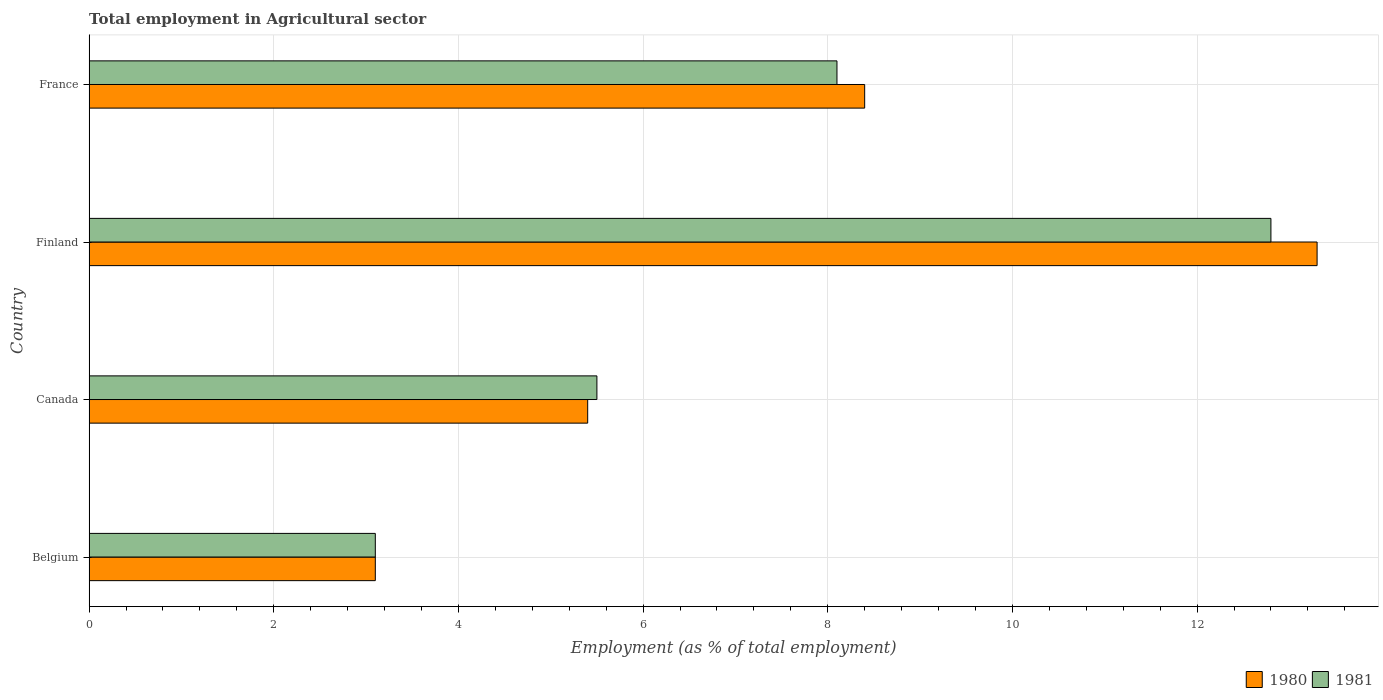How many groups of bars are there?
Provide a succinct answer. 4. Are the number of bars on each tick of the Y-axis equal?
Offer a very short reply. Yes. How many bars are there on the 4th tick from the top?
Your response must be concise. 2. What is the employment in agricultural sector in 1981 in Finland?
Provide a short and direct response. 12.8. Across all countries, what is the maximum employment in agricultural sector in 1980?
Ensure brevity in your answer.  13.3. Across all countries, what is the minimum employment in agricultural sector in 1980?
Keep it short and to the point. 3.1. In which country was the employment in agricultural sector in 1980 maximum?
Provide a succinct answer. Finland. In which country was the employment in agricultural sector in 1981 minimum?
Ensure brevity in your answer.  Belgium. What is the total employment in agricultural sector in 1980 in the graph?
Offer a terse response. 30.2. What is the difference between the employment in agricultural sector in 1981 in Canada and that in France?
Provide a short and direct response. -2.6. What is the difference between the employment in agricultural sector in 1981 in Finland and the employment in agricultural sector in 1980 in Belgium?
Your response must be concise. 9.7. What is the average employment in agricultural sector in 1980 per country?
Ensure brevity in your answer.  7.55. What is the difference between the employment in agricultural sector in 1980 and employment in agricultural sector in 1981 in France?
Ensure brevity in your answer.  0.3. What is the ratio of the employment in agricultural sector in 1981 in Canada to that in Finland?
Provide a succinct answer. 0.43. What is the difference between the highest and the second highest employment in agricultural sector in 1980?
Provide a succinct answer. 4.9. What is the difference between the highest and the lowest employment in agricultural sector in 1980?
Provide a short and direct response. 10.2. Is the sum of the employment in agricultural sector in 1980 in Finland and France greater than the maximum employment in agricultural sector in 1981 across all countries?
Your response must be concise. Yes. How many bars are there?
Offer a very short reply. 8. How many countries are there in the graph?
Your response must be concise. 4. What is the difference between two consecutive major ticks on the X-axis?
Provide a short and direct response. 2. Does the graph contain any zero values?
Provide a short and direct response. No. Where does the legend appear in the graph?
Make the answer very short. Bottom right. How many legend labels are there?
Your answer should be very brief. 2. How are the legend labels stacked?
Keep it short and to the point. Horizontal. What is the title of the graph?
Provide a short and direct response. Total employment in Agricultural sector. What is the label or title of the X-axis?
Give a very brief answer. Employment (as % of total employment). What is the label or title of the Y-axis?
Give a very brief answer. Country. What is the Employment (as % of total employment) of 1980 in Belgium?
Provide a succinct answer. 3.1. What is the Employment (as % of total employment) of 1981 in Belgium?
Provide a short and direct response. 3.1. What is the Employment (as % of total employment) in 1980 in Canada?
Your response must be concise. 5.4. What is the Employment (as % of total employment) of 1980 in Finland?
Give a very brief answer. 13.3. What is the Employment (as % of total employment) in 1981 in Finland?
Give a very brief answer. 12.8. What is the Employment (as % of total employment) in 1980 in France?
Ensure brevity in your answer.  8.4. What is the Employment (as % of total employment) of 1981 in France?
Give a very brief answer. 8.1. Across all countries, what is the maximum Employment (as % of total employment) of 1980?
Ensure brevity in your answer.  13.3. Across all countries, what is the maximum Employment (as % of total employment) in 1981?
Provide a succinct answer. 12.8. Across all countries, what is the minimum Employment (as % of total employment) of 1980?
Keep it short and to the point. 3.1. Across all countries, what is the minimum Employment (as % of total employment) in 1981?
Provide a succinct answer. 3.1. What is the total Employment (as % of total employment) in 1980 in the graph?
Ensure brevity in your answer.  30.2. What is the total Employment (as % of total employment) of 1981 in the graph?
Make the answer very short. 29.5. What is the difference between the Employment (as % of total employment) of 1980 in Belgium and that in Canada?
Provide a short and direct response. -2.3. What is the difference between the Employment (as % of total employment) in 1981 in Belgium and that in Canada?
Provide a short and direct response. -2.4. What is the difference between the Employment (as % of total employment) in 1981 in Belgium and that in Finland?
Give a very brief answer. -9.7. What is the difference between the Employment (as % of total employment) in 1980 in Belgium and that in France?
Your answer should be compact. -5.3. What is the difference between the Employment (as % of total employment) of 1981 in Belgium and that in France?
Offer a very short reply. -5. What is the difference between the Employment (as % of total employment) in 1980 in Canada and that in Finland?
Your answer should be compact. -7.9. What is the difference between the Employment (as % of total employment) of 1981 in Canada and that in Finland?
Offer a terse response. -7.3. What is the difference between the Employment (as % of total employment) in 1980 in Canada and that in France?
Provide a succinct answer. -3. What is the difference between the Employment (as % of total employment) of 1980 in Finland and that in France?
Ensure brevity in your answer.  4.9. What is the difference between the Employment (as % of total employment) of 1981 in Finland and that in France?
Your answer should be compact. 4.7. What is the difference between the Employment (as % of total employment) of 1980 in Belgium and the Employment (as % of total employment) of 1981 in France?
Make the answer very short. -5. What is the average Employment (as % of total employment) in 1980 per country?
Provide a short and direct response. 7.55. What is the average Employment (as % of total employment) in 1981 per country?
Give a very brief answer. 7.38. What is the difference between the Employment (as % of total employment) in 1980 and Employment (as % of total employment) in 1981 in Belgium?
Provide a short and direct response. 0. What is the difference between the Employment (as % of total employment) in 1980 and Employment (as % of total employment) in 1981 in Canada?
Give a very brief answer. -0.1. What is the difference between the Employment (as % of total employment) in 1980 and Employment (as % of total employment) in 1981 in Finland?
Your answer should be very brief. 0.5. What is the difference between the Employment (as % of total employment) in 1980 and Employment (as % of total employment) in 1981 in France?
Give a very brief answer. 0.3. What is the ratio of the Employment (as % of total employment) of 1980 in Belgium to that in Canada?
Your answer should be compact. 0.57. What is the ratio of the Employment (as % of total employment) of 1981 in Belgium to that in Canada?
Offer a very short reply. 0.56. What is the ratio of the Employment (as % of total employment) of 1980 in Belgium to that in Finland?
Your response must be concise. 0.23. What is the ratio of the Employment (as % of total employment) in 1981 in Belgium to that in Finland?
Your response must be concise. 0.24. What is the ratio of the Employment (as % of total employment) of 1980 in Belgium to that in France?
Offer a terse response. 0.37. What is the ratio of the Employment (as % of total employment) in 1981 in Belgium to that in France?
Give a very brief answer. 0.38. What is the ratio of the Employment (as % of total employment) of 1980 in Canada to that in Finland?
Ensure brevity in your answer.  0.41. What is the ratio of the Employment (as % of total employment) in 1981 in Canada to that in Finland?
Your response must be concise. 0.43. What is the ratio of the Employment (as % of total employment) of 1980 in Canada to that in France?
Offer a very short reply. 0.64. What is the ratio of the Employment (as % of total employment) in 1981 in Canada to that in France?
Keep it short and to the point. 0.68. What is the ratio of the Employment (as % of total employment) in 1980 in Finland to that in France?
Offer a very short reply. 1.58. What is the ratio of the Employment (as % of total employment) of 1981 in Finland to that in France?
Keep it short and to the point. 1.58. What is the difference between the highest and the second highest Employment (as % of total employment) of 1981?
Your response must be concise. 4.7. What is the difference between the highest and the lowest Employment (as % of total employment) in 1980?
Provide a short and direct response. 10.2. What is the difference between the highest and the lowest Employment (as % of total employment) of 1981?
Your answer should be compact. 9.7. 